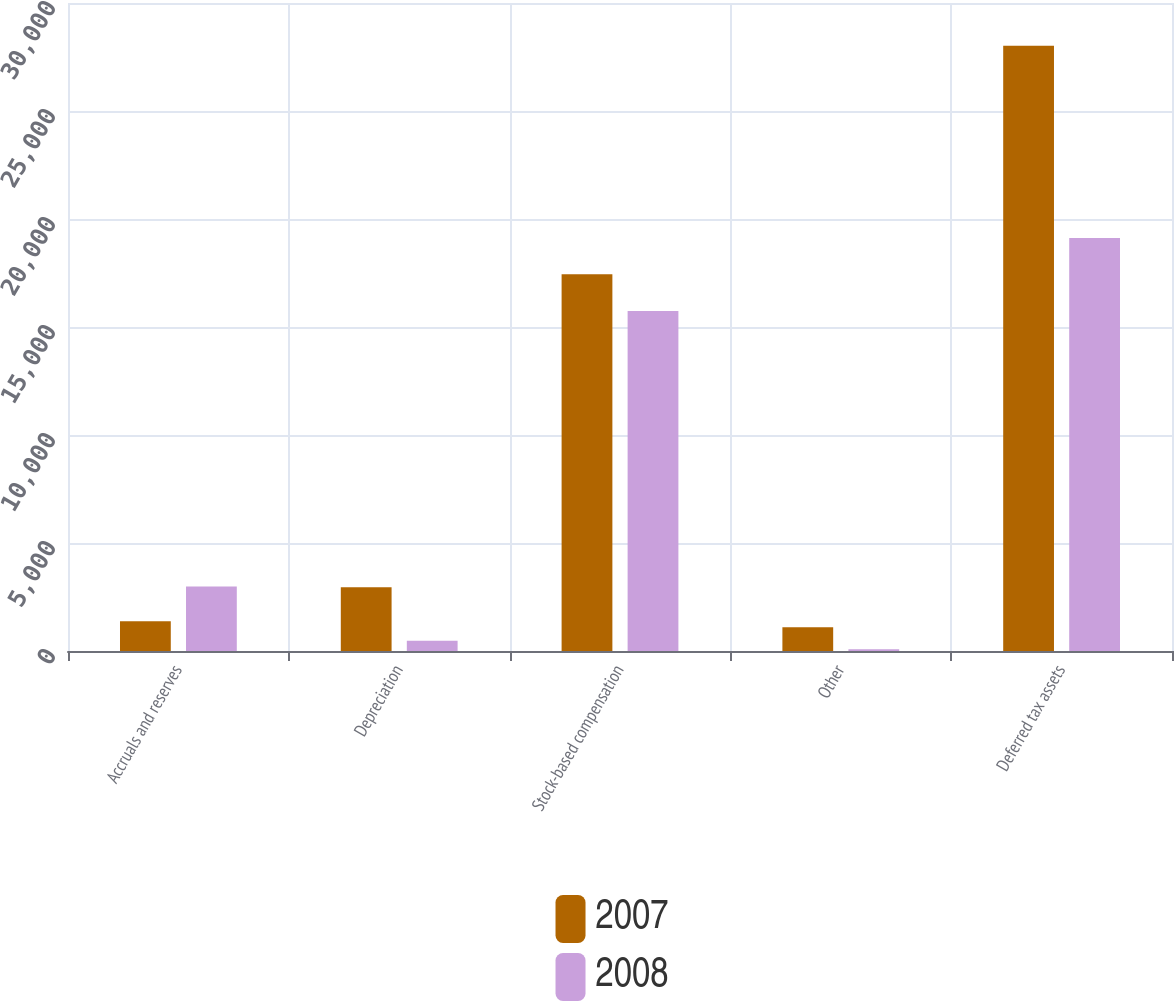Convert chart to OTSL. <chart><loc_0><loc_0><loc_500><loc_500><stacked_bar_chart><ecel><fcel>Accruals and reserves<fcel>Depreciation<fcel>Stock-based compensation<fcel>Other<fcel>Deferred tax assets<nl><fcel>2007<fcel>1378<fcel>2947<fcel>17440<fcel>1103<fcel>28026<nl><fcel>2008<fcel>2986<fcel>473<fcel>15736<fcel>76<fcel>19119<nl></chart> 